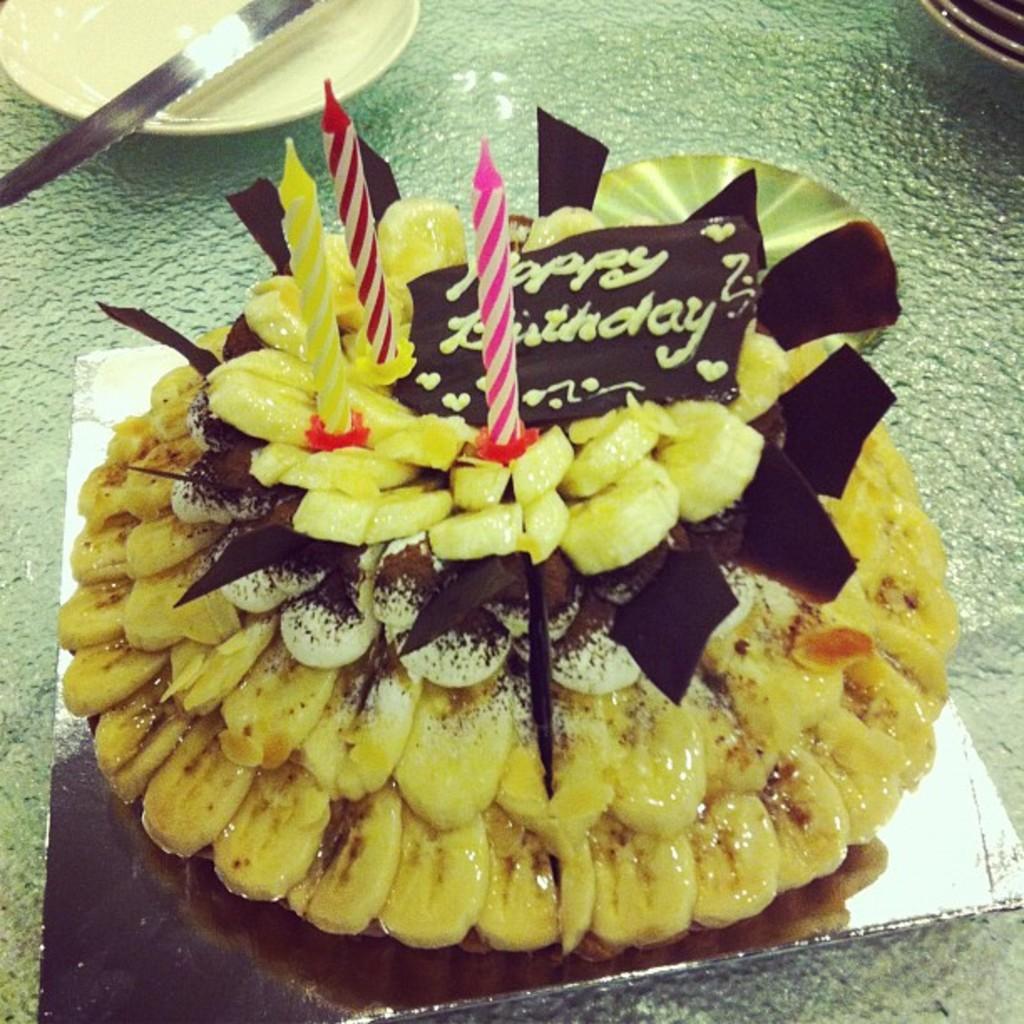Could you give a brief overview of what you see in this image? In the foreground of the picture there is a cake, on the cake there are candles. On the left there is a plate and knife. On the right there are plates. 